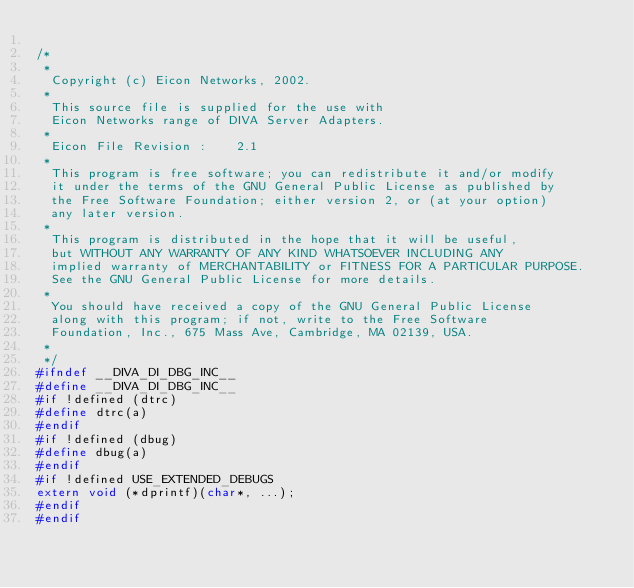<code> <loc_0><loc_0><loc_500><loc_500><_C_>
/*
 *
  Copyright (c) Eicon Networks, 2002.
 *
  This source file is supplied for the use with
  Eicon Networks range of DIVA Server Adapters.
 *
  Eicon File Revision :    2.1
 *
  This program is free software; you can redistribute it and/or modify
  it under the terms of the GNU General Public License as published by
  the Free Software Foundation; either version 2, or (at your option)
  any later version.
 *
  This program is distributed in the hope that it will be useful,
  but WITHOUT ANY WARRANTY OF ANY KIND WHATSOEVER INCLUDING ANY
  implied warranty of MERCHANTABILITY or FITNESS FOR A PARTICULAR PURPOSE.
  See the GNU General Public License for more details.
 *
  You should have received a copy of the GNU General Public License
  along with this program; if not, write to the Free Software
  Foundation, Inc., 675 Mass Ave, Cambridge, MA 02139, USA.
 *
 */
#ifndef __DIVA_DI_DBG_INC__
#define __DIVA_DI_DBG_INC__
#if !defined (dtrc)
#define dtrc(a)
#endif
#if !defined (dbug)
#define dbug(a)
#endif
#if !defined USE_EXTENDED_DEBUGS
extern void (*dprintf)(char*, ...);
#endif
#endif
</code> 